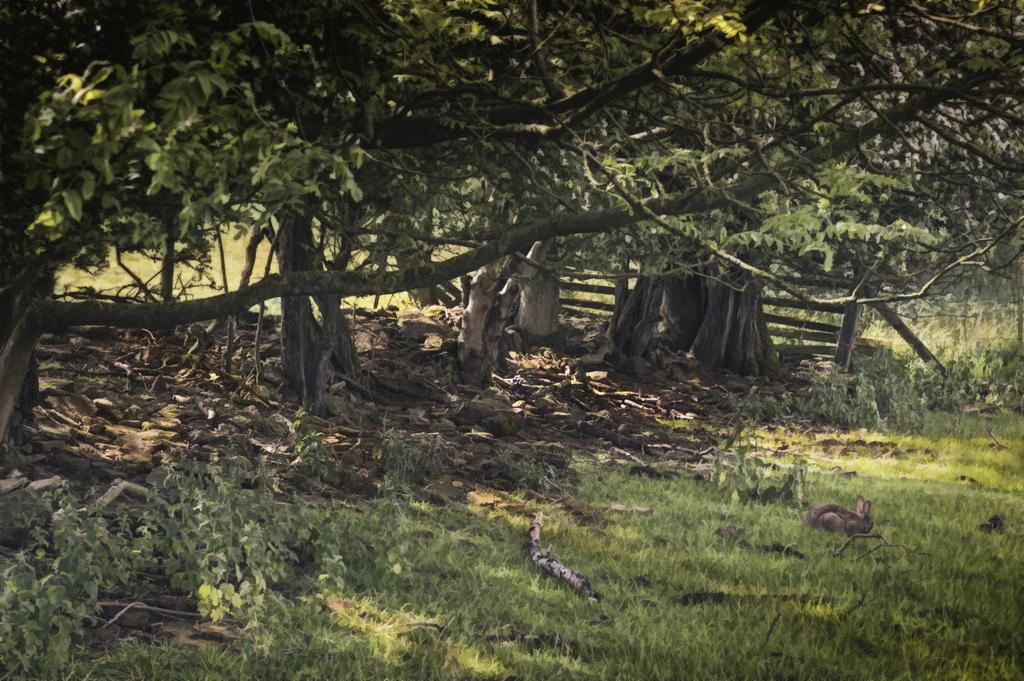What type of surface covers the entire area in the image? The entire area in the image is covered with grass. What type of vegetation can be seen in the image? Plants and trees are visible in the image. What type of lock is used to secure the pencil in the image? There is no lock or pencil present in the image. 